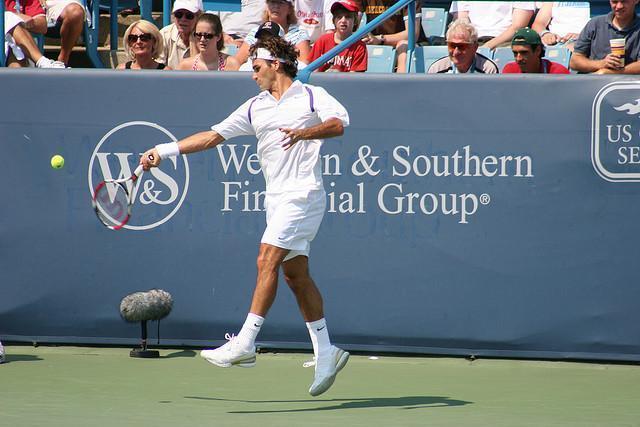What is traveling towards the man?
Pick the right solution, then justify: 'Answer: answer
Rationale: rationale.'
Options: Tennis ball, dog, cow, bee. Answer: tennis ball.
Rationale: The ball is moving toward him. 